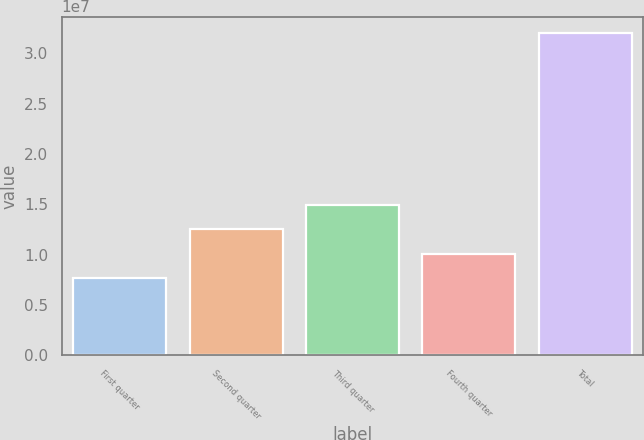<chart> <loc_0><loc_0><loc_500><loc_500><bar_chart><fcel>First quarter<fcel>Second quarter<fcel>Third quarter<fcel>Fourth quarter<fcel>Total<nl><fcel>7.64e+06<fcel>1.25207e+07<fcel>1.4961e+07<fcel>1.00803e+07<fcel>3.20434e+07<nl></chart> 